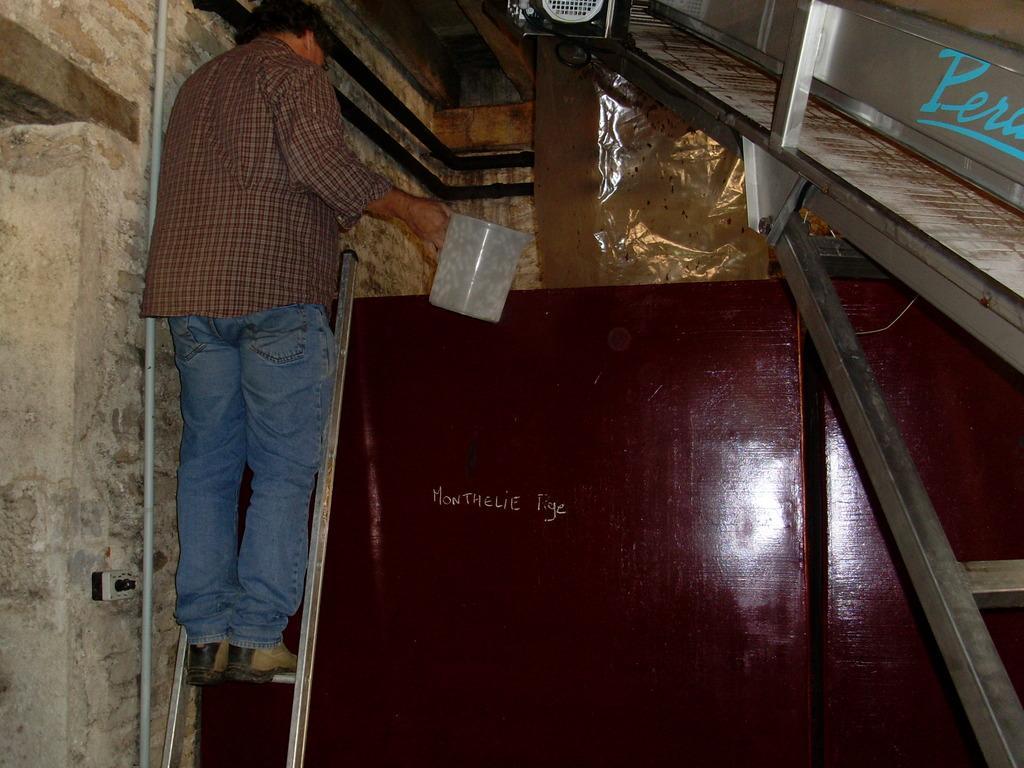Please provide a concise description of this image. In this image, we can see a person is standing on the ladder and holding some container. Here there is a wall, pipe, rods and cover. 